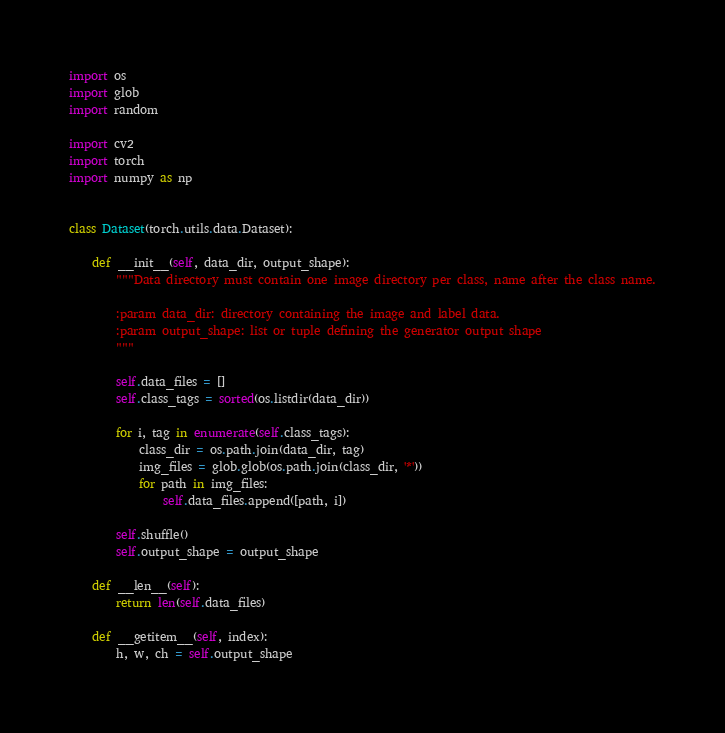Convert code to text. <code><loc_0><loc_0><loc_500><loc_500><_Python_>import os
import glob
import random

import cv2
import torch
import numpy as np


class Dataset(torch.utils.data.Dataset):

    def __init__(self, data_dir, output_shape):
        """Data directory must contain one image directory per class, name after the class name.

        :param data_dir: directory containing the image and label data.
        :param output_shape: list or tuple defining the generator output shape
        """

        self.data_files = []
        self.class_tags = sorted(os.listdir(data_dir))

        for i, tag in enumerate(self.class_tags):
            class_dir = os.path.join(data_dir, tag)
            img_files = glob.glob(os.path.join(class_dir, '*'))
            for path in img_files:
                self.data_files.append([path, i])

        self.shuffle()
        self.output_shape = output_shape

    def __len__(self):
        return len(self.data_files)

    def __getitem__(self, index):
        h, w, ch = self.output_shape
</code> 